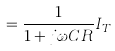Convert formula to latex. <formula><loc_0><loc_0><loc_500><loc_500>= \frac { 1 } { 1 + j \omega C R } I _ { T }</formula> 